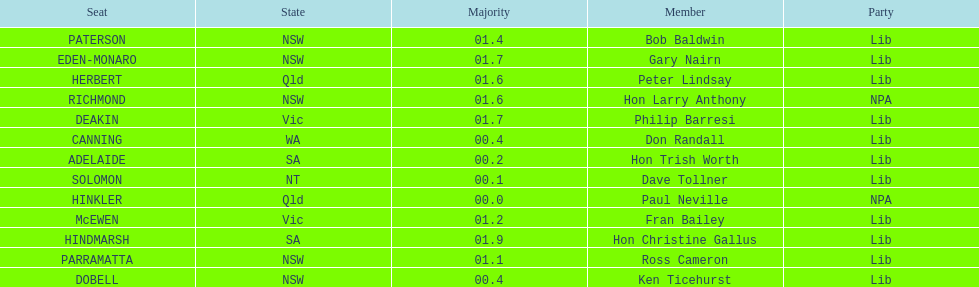What party had the most seats? Lib. 